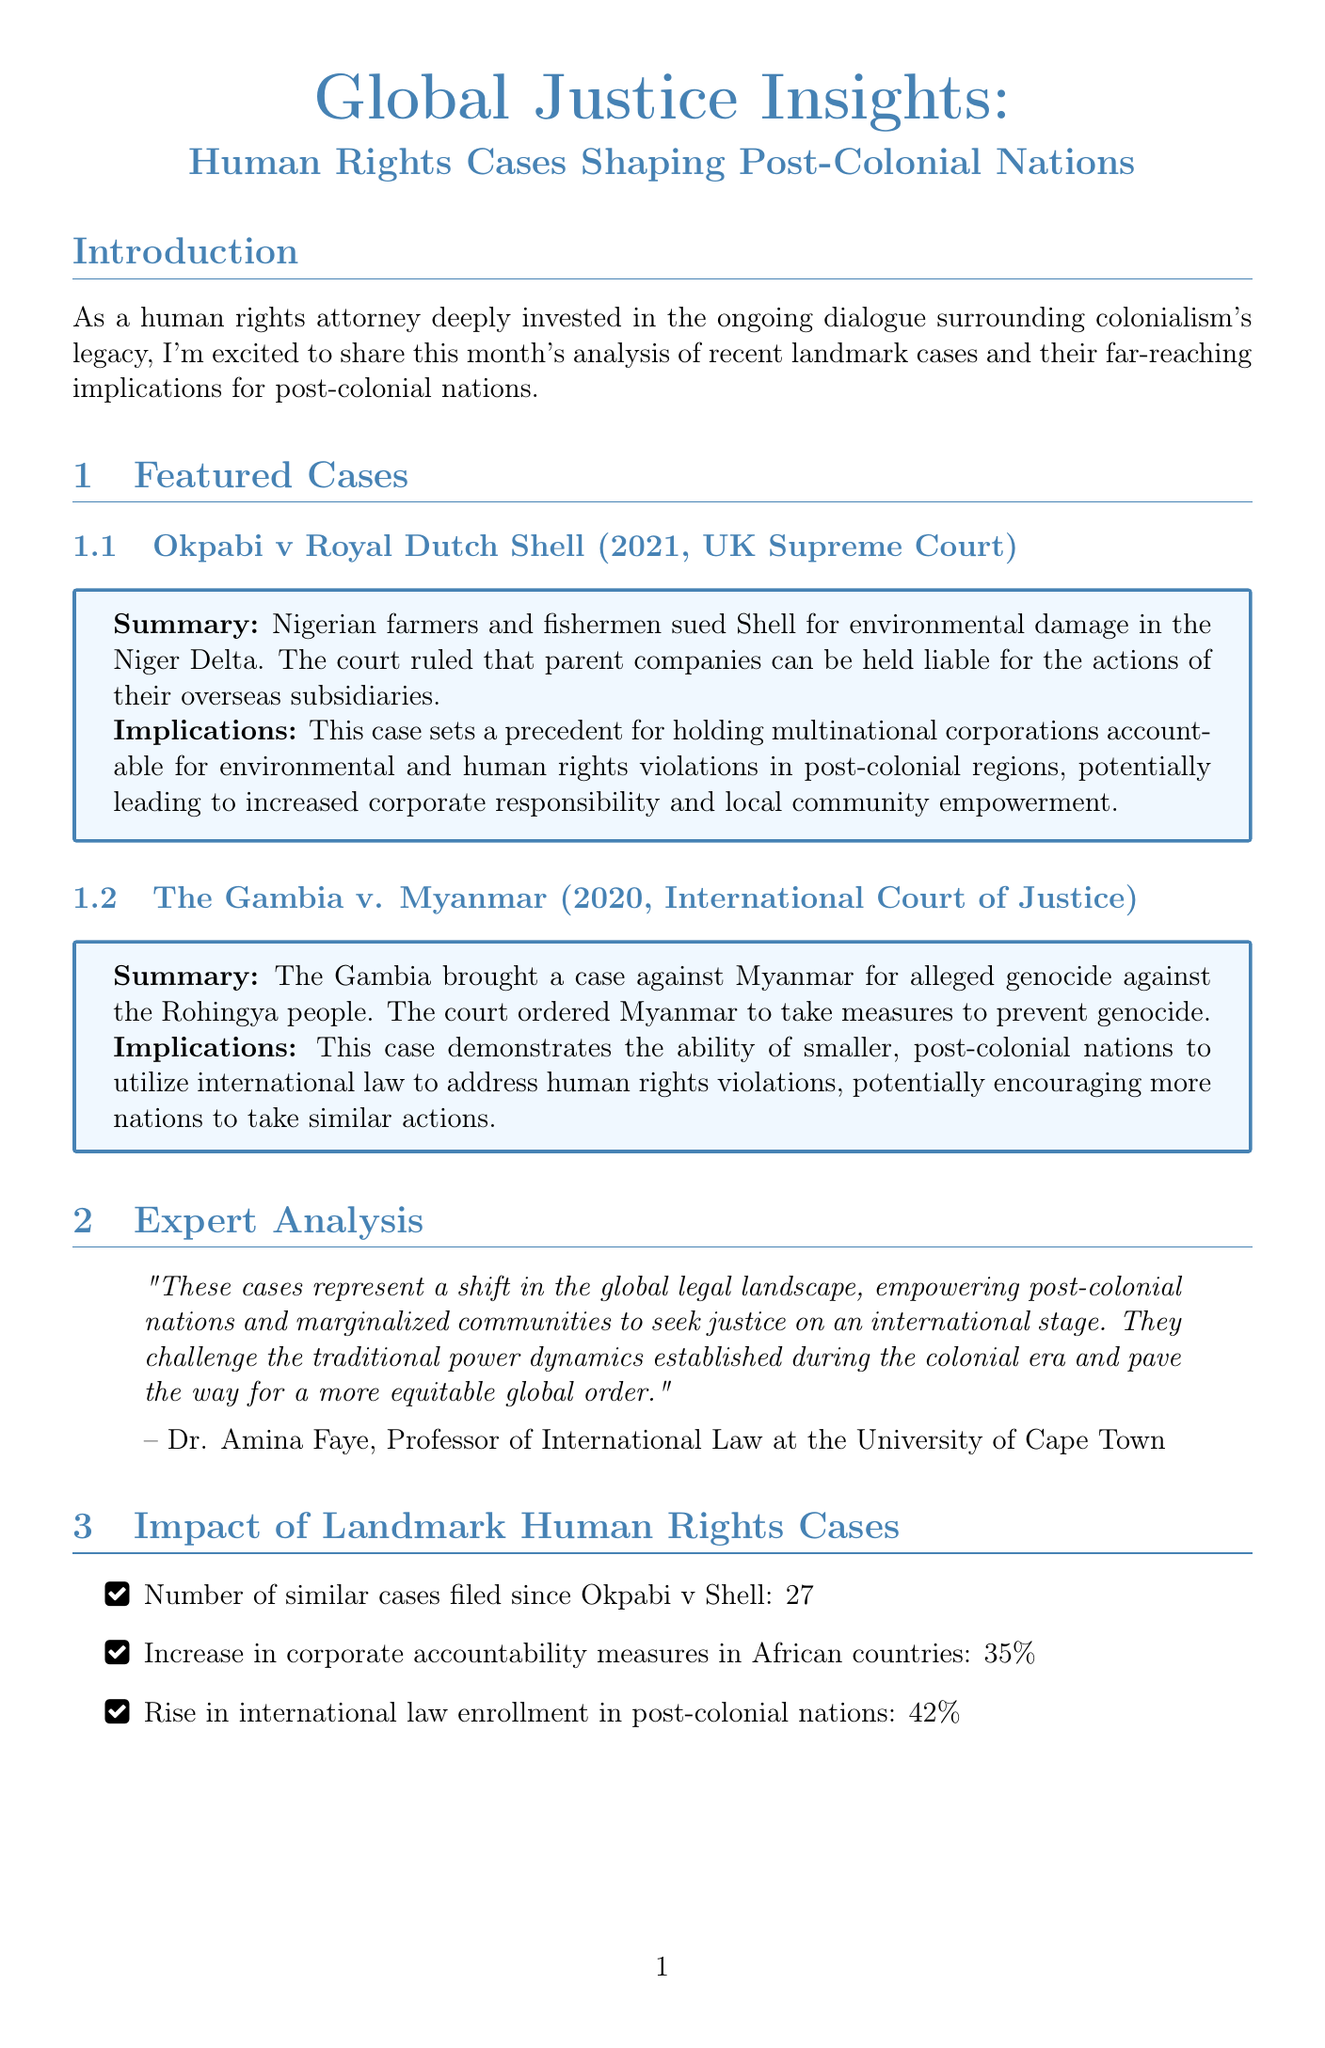What is the title of the newsletter? The title of the newsletter is stated at the top of the document.
Answer: Global Justice Insights: Human Rights Cases Shaping Post-Colonial Nations Which case was decided by the UK Supreme Court? The case decided by the UK Supreme Court is listed under featured cases with the court's name.
Answer: Okpabi v Royal Dutch Shell In which year did The Gambia v. Myanmar take place? The year of the case is provided alongside the case name in the document.
Answer: 2020 What percentage increase in corporate accountability measures is noted? The document provides a data point reflecting the increase in corporate accountability measures.
Answer: 35% Who is the author of the expert analysis? The author's name is included in the expert analysis section of the newsletter.
Answer: Dr. Amina Faye How many similar cases have been filed since Okpabi v Shell? The number of similar cases filed is a data point within the infographic section of the document.
Answer: 27 What role does the newsletter attribute to international law? The newsletter discusses the role of international law in a discussion point section.
Answer: Addressing historical injustices How might these rulings influence future foreign investment? This question is posed in the discussion points, prompting readers to think critically.
Answer: Influence future foreign investment What is the closing sentiment of the newsletter? The closing thoughts summarize the overall sentiment expressed in the newsletter.
Answer: Hope for a more just global order 